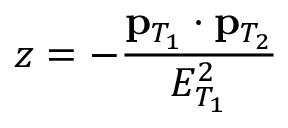<formula> <loc_0><loc_0><loc_500><loc_500>z = - \frac { { p } _ { T _ { 1 } } \cdot { p } _ { T _ { 2 } } } { E _ { T _ { 1 } } ^ { 2 } }</formula> 